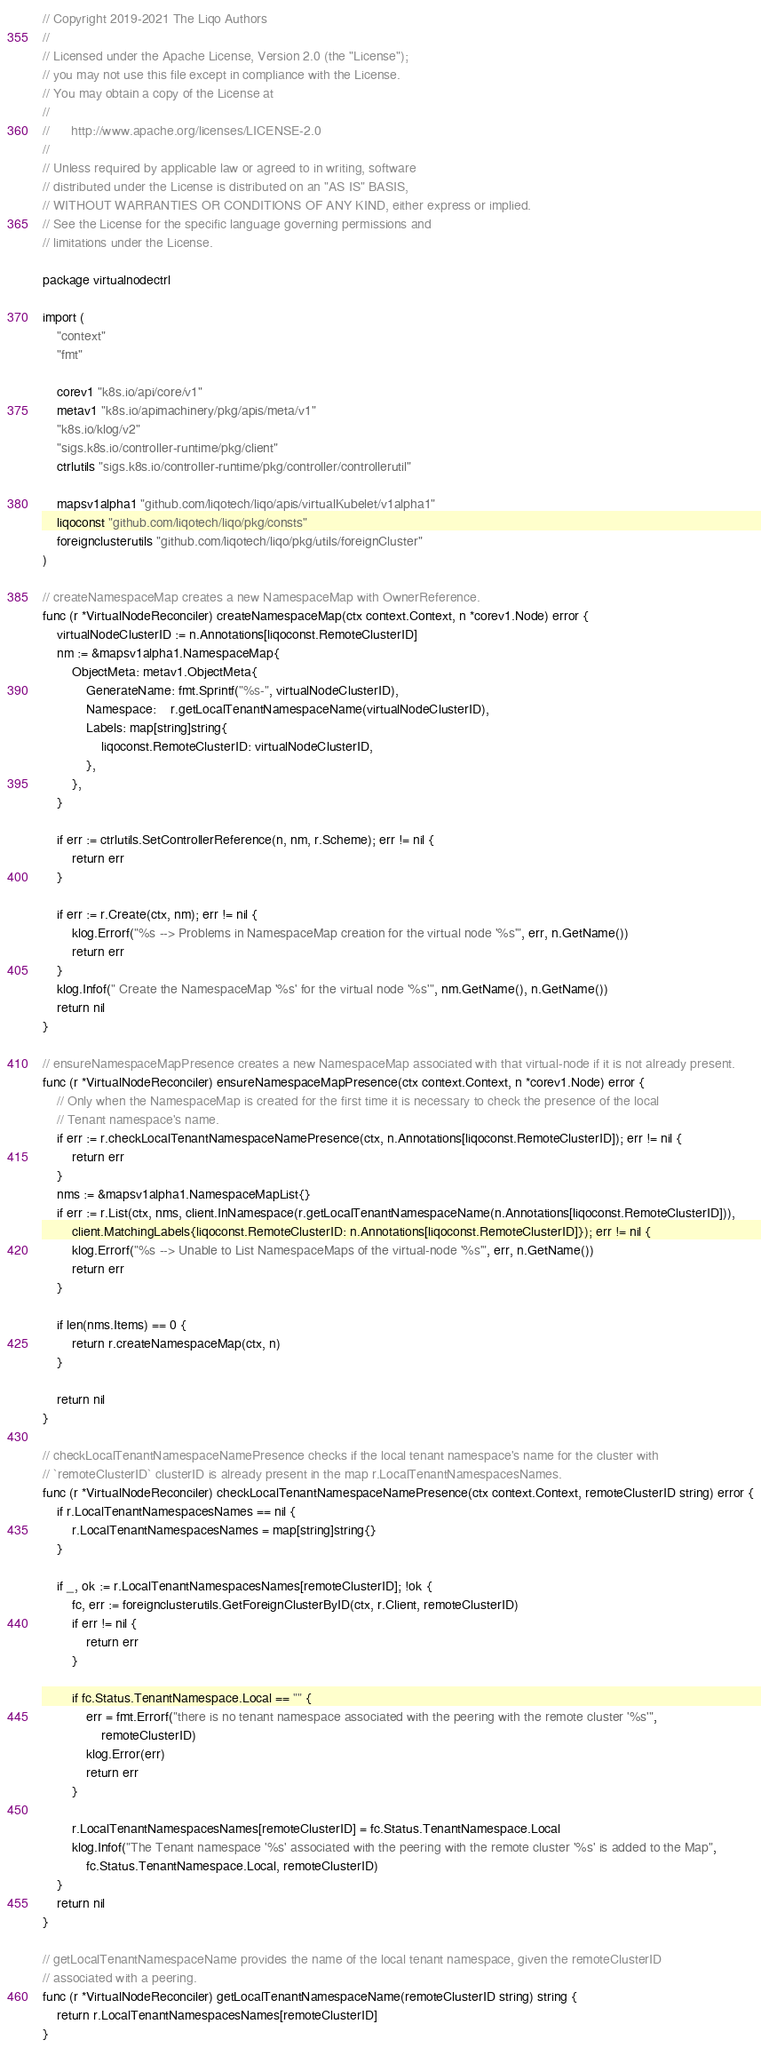Convert code to text. <code><loc_0><loc_0><loc_500><loc_500><_Go_>// Copyright 2019-2021 The Liqo Authors
//
// Licensed under the Apache License, Version 2.0 (the "License");
// you may not use this file except in compliance with the License.
// You may obtain a copy of the License at
//
//      http://www.apache.org/licenses/LICENSE-2.0
//
// Unless required by applicable law or agreed to in writing, software
// distributed under the License is distributed on an "AS IS" BASIS,
// WITHOUT WARRANTIES OR CONDITIONS OF ANY KIND, either express or implied.
// See the License for the specific language governing permissions and
// limitations under the License.

package virtualnodectrl

import (
	"context"
	"fmt"

	corev1 "k8s.io/api/core/v1"
	metav1 "k8s.io/apimachinery/pkg/apis/meta/v1"
	"k8s.io/klog/v2"
	"sigs.k8s.io/controller-runtime/pkg/client"
	ctrlutils "sigs.k8s.io/controller-runtime/pkg/controller/controllerutil"

	mapsv1alpha1 "github.com/liqotech/liqo/apis/virtualKubelet/v1alpha1"
	liqoconst "github.com/liqotech/liqo/pkg/consts"
	foreignclusterutils "github.com/liqotech/liqo/pkg/utils/foreignCluster"
)

// createNamespaceMap creates a new NamespaceMap with OwnerReference.
func (r *VirtualNodeReconciler) createNamespaceMap(ctx context.Context, n *corev1.Node) error {
	virtualNodeClusterID := n.Annotations[liqoconst.RemoteClusterID]
	nm := &mapsv1alpha1.NamespaceMap{
		ObjectMeta: metav1.ObjectMeta{
			GenerateName: fmt.Sprintf("%s-", virtualNodeClusterID),
			Namespace:    r.getLocalTenantNamespaceName(virtualNodeClusterID),
			Labels: map[string]string{
				liqoconst.RemoteClusterID: virtualNodeClusterID,
			},
		},
	}

	if err := ctrlutils.SetControllerReference(n, nm, r.Scheme); err != nil {
		return err
	}

	if err := r.Create(ctx, nm); err != nil {
		klog.Errorf("%s --> Problems in NamespaceMap creation for the virtual node '%s'", err, n.GetName())
		return err
	}
	klog.Infof(" Create the NamespaceMap '%s' for the virtual node '%s'", nm.GetName(), n.GetName())
	return nil
}

// ensureNamespaceMapPresence creates a new NamespaceMap associated with that virtual-node if it is not already present.
func (r *VirtualNodeReconciler) ensureNamespaceMapPresence(ctx context.Context, n *corev1.Node) error {
	// Only when the NamespaceMap is created for the first time it is necessary to check the presence of the local
	// Tenant namespace's name.
	if err := r.checkLocalTenantNamespaceNamePresence(ctx, n.Annotations[liqoconst.RemoteClusterID]); err != nil {
		return err
	}
	nms := &mapsv1alpha1.NamespaceMapList{}
	if err := r.List(ctx, nms, client.InNamespace(r.getLocalTenantNamespaceName(n.Annotations[liqoconst.RemoteClusterID])),
		client.MatchingLabels{liqoconst.RemoteClusterID: n.Annotations[liqoconst.RemoteClusterID]}); err != nil {
		klog.Errorf("%s --> Unable to List NamespaceMaps of the virtual-node '%s'", err, n.GetName())
		return err
	}

	if len(nms.Items) == 0 {
		return r.createNamespaceMap(ctx, n)
	}

	return nil
}

// checkLocalTenantNamespaceNamePresence checks if the local tenant namespace's name for the cluster with
// `remoteClusterID` clusterID is already present in the map r.LocalTenantNamespacesNames.
func (r *VirtualNodeReconciler) checkLocalTenantNamespaceNamePresence(ctx context.Context, remoteClusterID string) error {
	if r.LocalTenantNamespacesNames == nil {
		r.LocalTenantNamespacesNames = map[string]string{}
	}

	if _, ok := r.LocalTenantNamespacesNames[remoteClusterID]; !ok {
		fc, err := foreignclusterutils.GetForeignClusterByID(ctx, r.Client, remoteClusterID)
		if err != nil {
			return err
		}

		if fc.Status.TenantNamespace.Local == "" {
			err = fmt.Errorf("there is no tenant namespace associated with the peering with the remote cluster '%s'",
				remoteClusterID)
			klog.Error(err)
			return err
		}

		r.LocalTenantNamespacesNames[remoteClusterID] = fc.Status.TenantNamespace.Local
		klog.Infof("The Tenant namespace '%s' associated with the peering with the remote cluster '%s' is added to the Map",
			fc.Status.TenantNamespace.Local, remoteClusterID)
	}
	return nil
}

// getLocalTenantNamespaceName provides the name of the local tenant namespace, given the remoteClusterID
// associated with a peering.
func (r *VirtualNodeReconciler) getLocalTenantNamespaceName(remoteClusterID string) string {
	return r.LocalTenantNamespacesNames[remoteClusterID]
}
</code> 